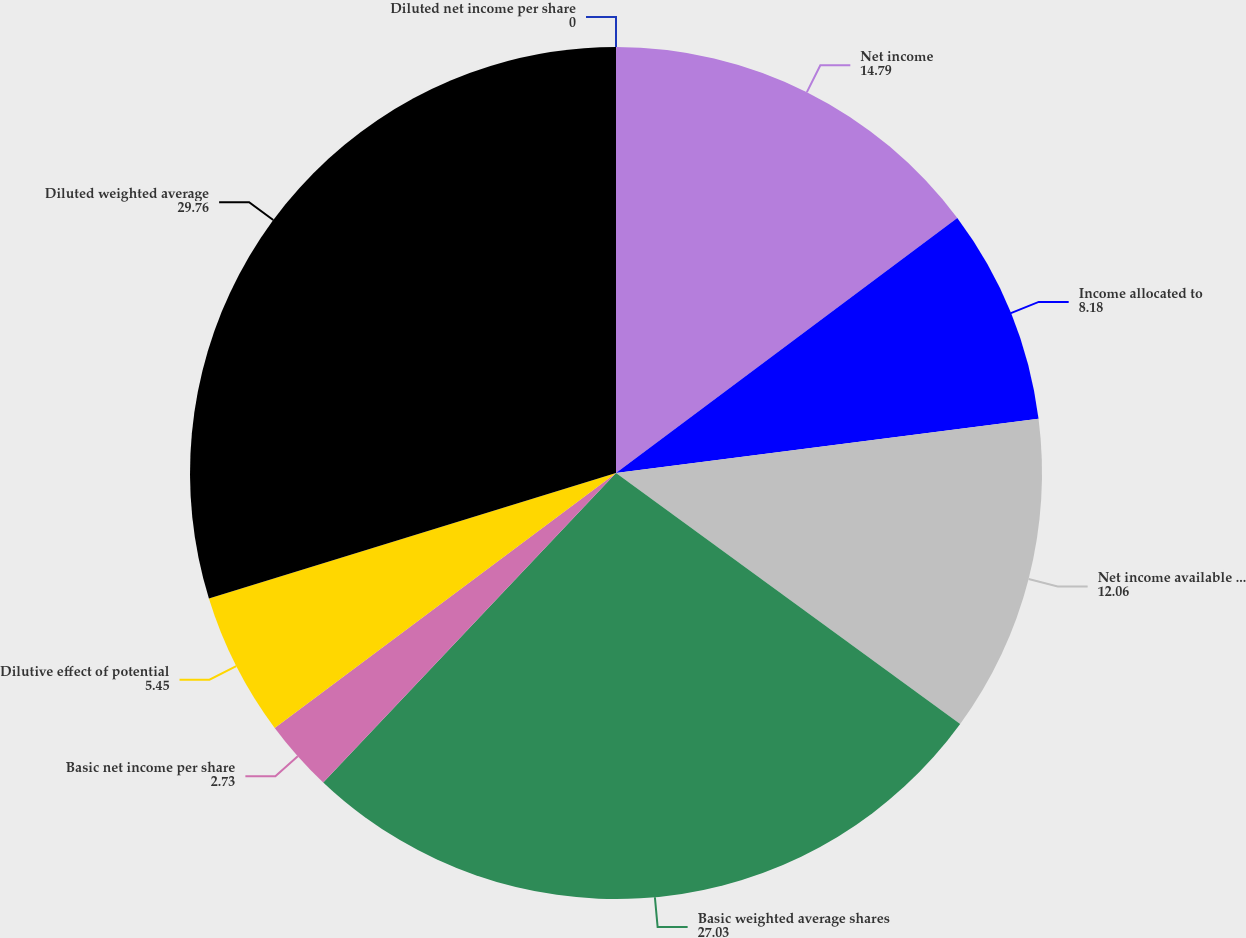Convert chart to OTSL. <chart><loc_0><loc_0><loc_500><loc_500><pie_chart><fcel>Net income<fcel>Income allocated to<fcel>Net income available to common<fcel>Basic weighted average shares<fcel>Basic net income per share<fcel>Dilutive effect of potential<fcel>Diluted weighted average<fcel>Diluted net income per share<nl><fcel>14.79%<fcel>8.18%<fcel>12.06%<fcel>27.03%<fcel>2.73%<fcel>5.45%<fcel>29.76%<fcel>0.0%<nl></chart> 